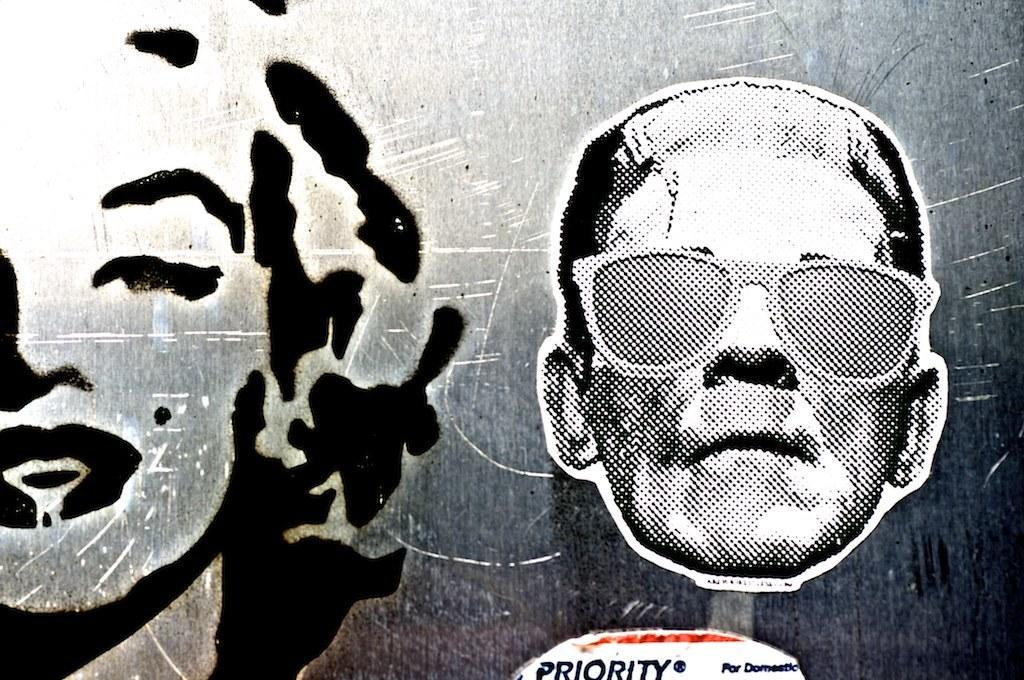What is the color scheme of the image? The image is black and white. What can be seen in the image? There is a person's face in the image. What accessory is the person wearing? The person is wearing glasses. Can you determine the gender of the person in the image? The person's face appears to be a woman's face. What else is present in the image besides the person's face? There is edited text on a board in the image. What type of comb is the woman using on her hair in the image? There is no comb visible in the image, and the woman's hair is not shown. Can you hear the woman speaking in the image? The image is a still photograph, so there is no sound or speech present. 